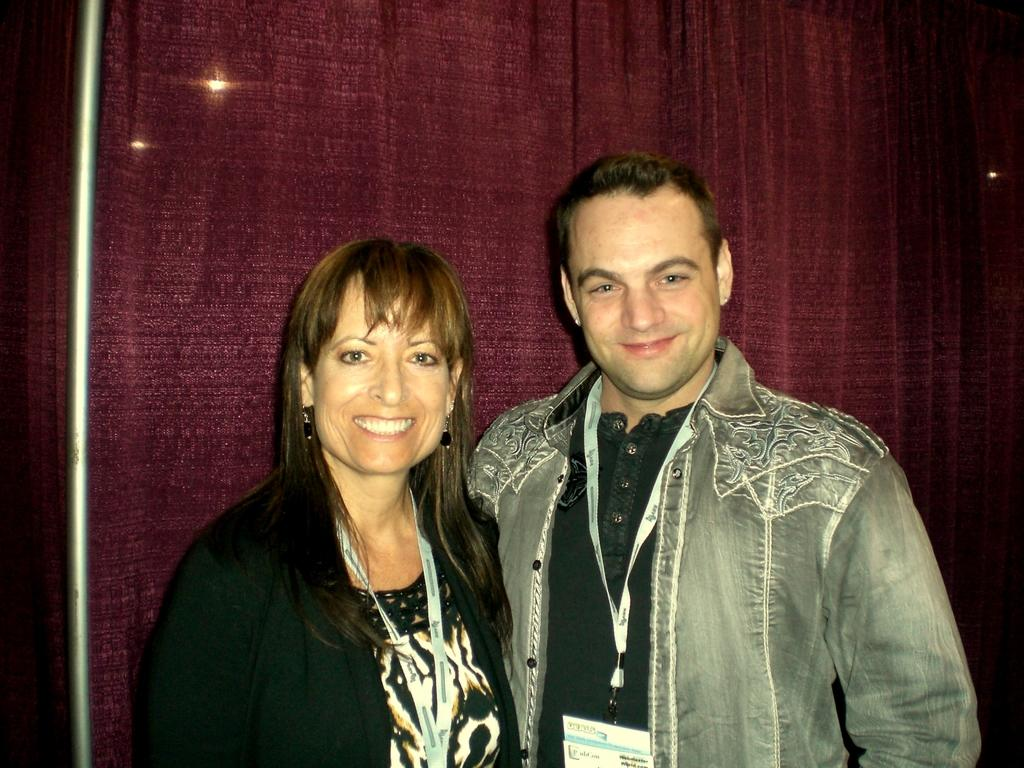How many people are present in the image? There are two people, a man and a woman, present in the image. What are the man and the woman wearing in the image? Both the man and the woman are wearing identity cards in the image. What expressions do the man and the woman have in the image? The man and the woman are smiling in the image. What can be seen in the background of the image? There is a curtain and lights in the background of the image. What is located on the left side of the image? There is a rod on the left side of the image. What type of cherries can be seen on the vacation in the image? There is no mention of cherries or a vacation in the image; it features a man and a woman wearing identity cards and smiling. 